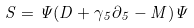<formula> <loc_0><loc_0><loc_500><loc_500>S = \Psi ( \sl { D } + \gamma _ { 5 } \partial _ { 5 } - M ) \Psi \\</formula> 